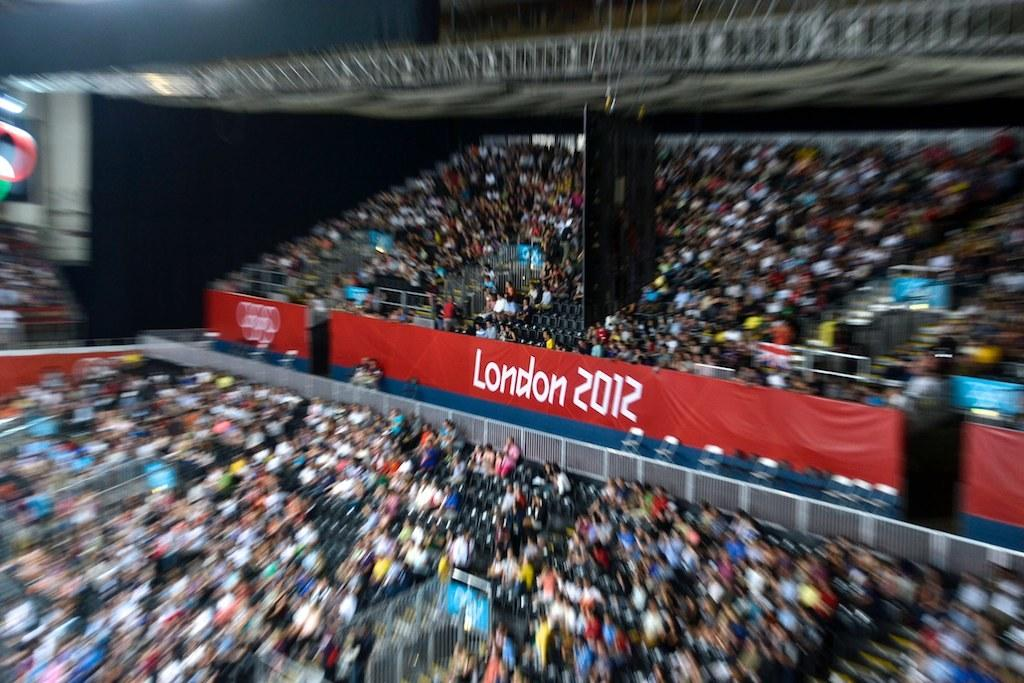What are the people in the image doing? The people in the image are sitting on stands. What can be seen hanging or displayed in the image? There is a red color banner with text in the image. Is there any information about the time or date in the image? Yes, the year is mentioned in the image. Can you describe the clarity of the image? Some parts of the image are blurred. What type of disease is being treated by the kite in the image? There is no kite present in the image, and therefore no treatment for any disease can be observed. What color is the underwear being worn by the people in the image? The provided facts do not mention any underwear, so we cannot determine the color of any underwear being worn by the people in the image. 